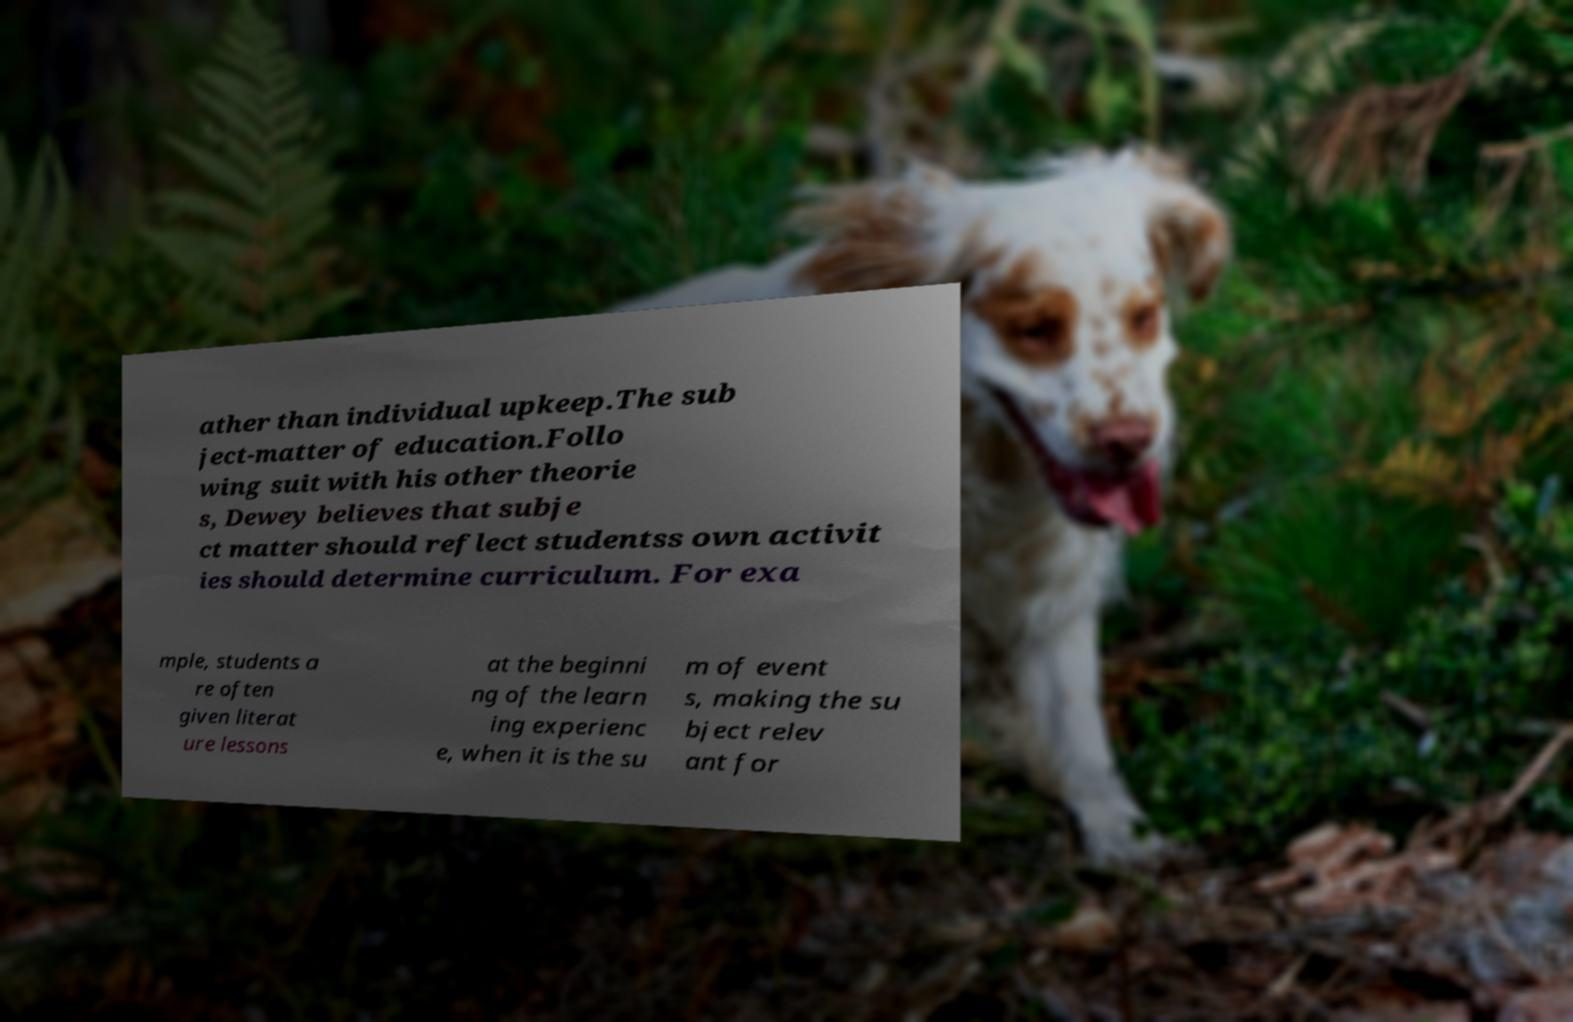I need the written content from this picture converted into text. Can you do that? ather than individual upkeep.The sub ject-matter of education.Follo wing suit with his other theorie s, Dewey believes that subje ct matter should reflect studentss own activit ies should determine curriculum. For exa mple, students a re often given literat ure lessons at the beginni ng of the learn ing experienc e, when it is the su m of event s, making the su bject relev ant for 